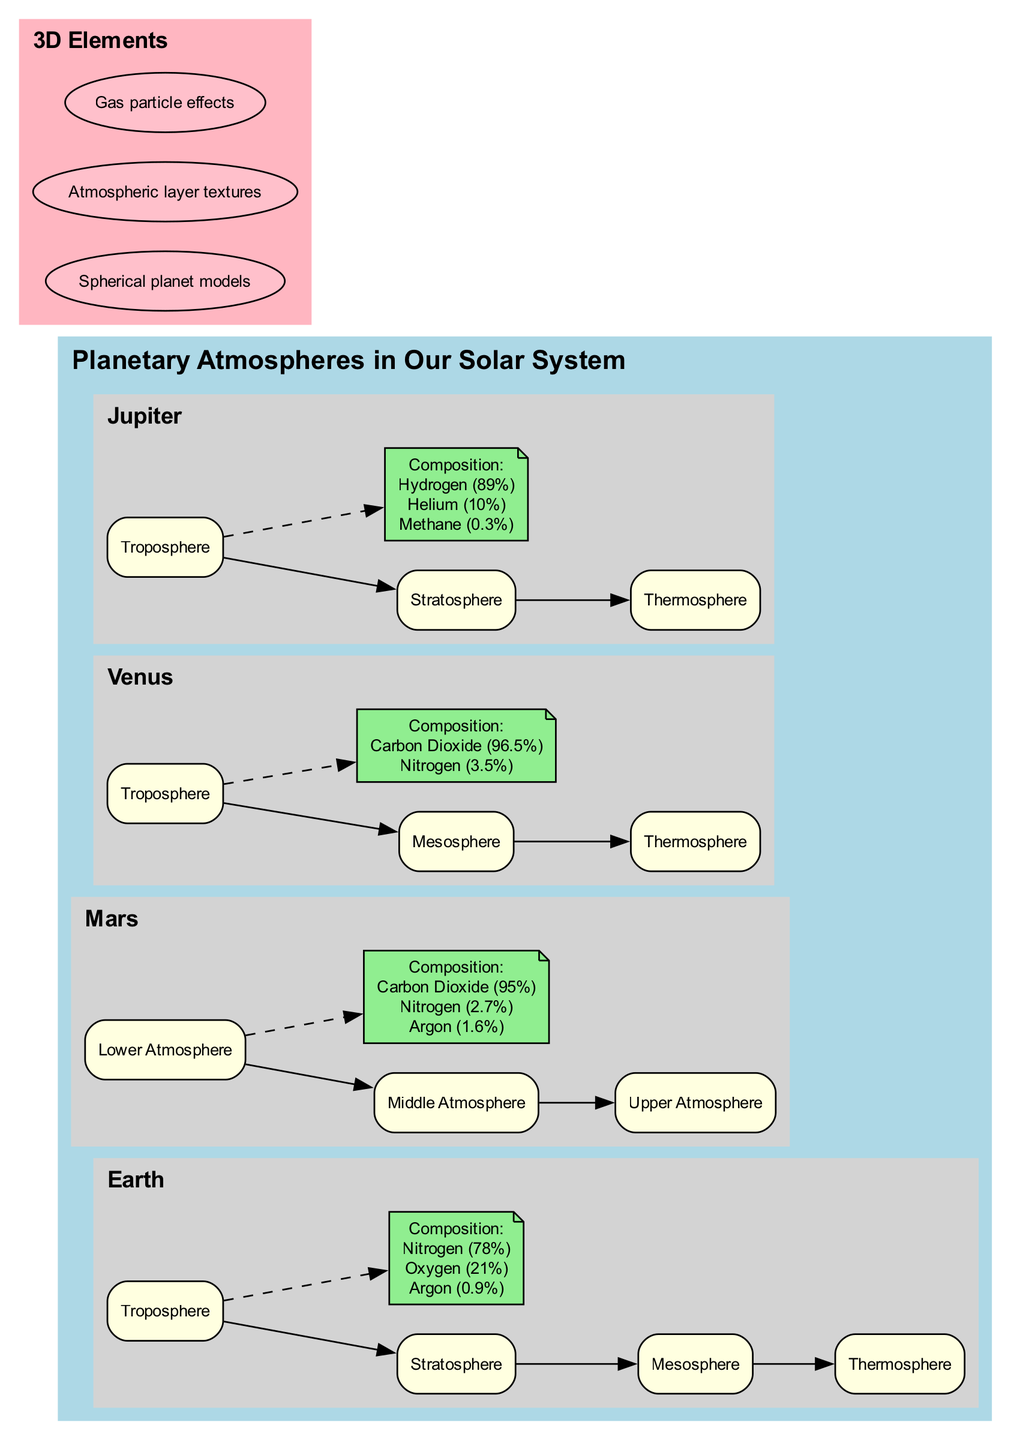What is the primary composition of Mars' atmosphere? The diagram lists Mars' atmospheric composition clearly, showing Carbon Dioxide as the main component with a percentage of 95%.
Answer: Carbon Dioxide (95%) How many layers does Venus have in its atmosphere? Upon inspecting the diagram, Venus has three distinct layers: Troposphere, Mesosphere, and Thermosphere, thus totaling three layers.
Answer: 3 Which planet has the highest concentration of Nitrogen in its atmosphere? By analyzing the atmosphere compositions in the diagram, Earth has a Nitrogen concentration of 21%, which is the highest among the presented planetary atmospheres.
Answer: Earth What type of atmosphere does Jupiter have? The diagram categorizes Jupiter's atmosphere into three layers: Troposphere, Stratosphere, and Thermosphere, all of which indicate that it consists of a gaseous atmosphere.
Answer: Gaseous Which atmospheric layer is present in Earth but not in Mars? The diagram includes Earth's Stratosphere while Mars' atmosphere is represented by Lower, Middle, and Upper Atmosphere, thus making the Stratosphere absent in Mars.
Answer: Stratosphere What percentage of Jupiter's atmosphere is composed of Hydrogen? Observing the composition section of Jupiter, it is specified that Hydrogen constitutes 89% of its atmosphere.
Answer: Hydrogen (89%) Which planet's atmosphere has a composition of over 90% carbon dioxide? The diagram indicates that both Venus and Mars have high carbon dioxide percentages, but Venus has 96.5%, which exceeds 90%.
Answer: Venus What color represents the composition nodes in the diagram? The diagram labels the composition nodes with the fill color light green, making this the identifiable color for these nodes.
Answer: Light green How many planets are represented in the diagram? A direct count from the diagram shows that four planets (Earth, Mars, Venus, Jupiter) are depicted, confirming this number.
Answer: 4 